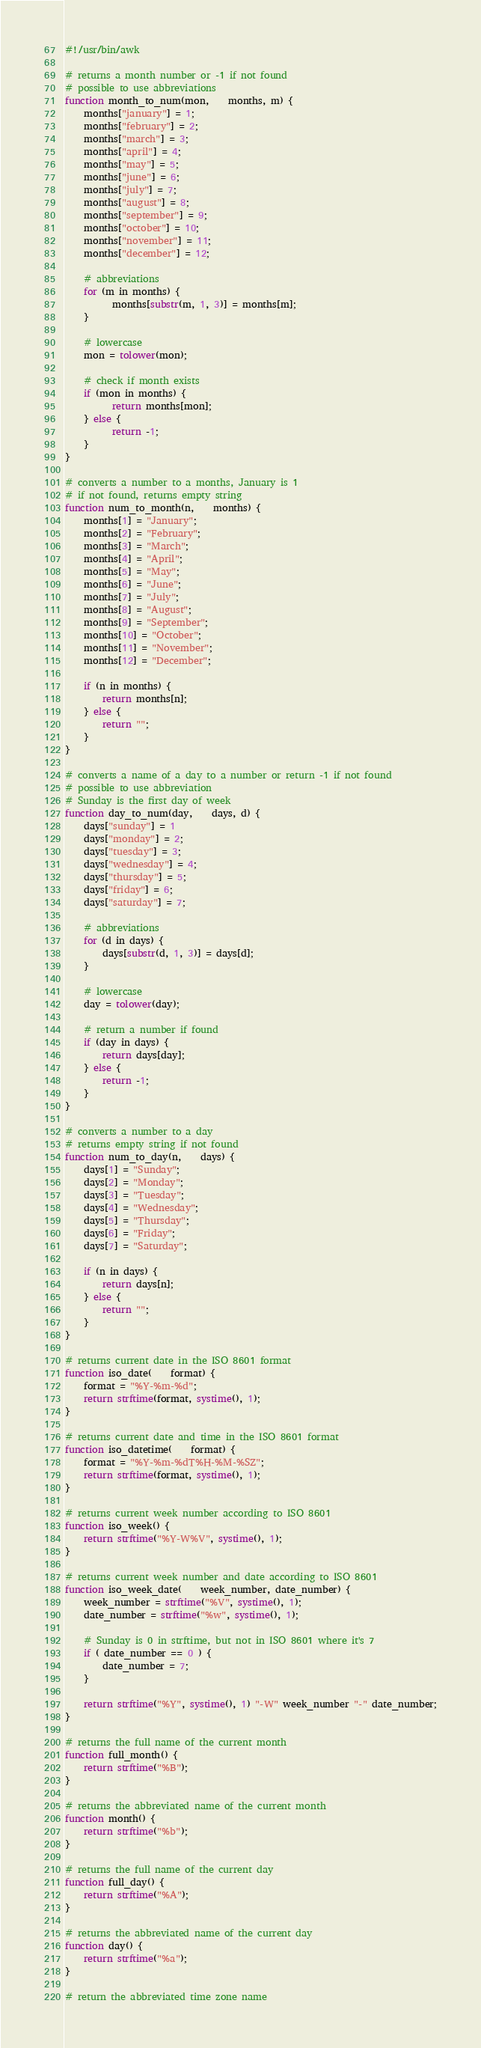Convert code to text. <code><loc_0><loc_0><loc_500><loc_500><_Awk_>#!/usr/bin/awk

# returns a month number or -1 if not found
# possible to use abbreviations
function month_to_num(mon,    months, m) {
	months["january"] = 1;
	months["february"] = 2;
	months["march"] = 3;
	months["april"] = 4;
	months["may"] = 5;
	months["june"] = 6;
	months["july"] = 7;
	months["august"] = 8;
	months["september"] = 9;
	months["october"] = 10;
	months["november"] = 11;
	months["december"] = 12;

	# abbreviations
	for (m in months) {
	      months[substr(m, 1, 3)] = months[m];
	}

	# lowercase
	mon = tolower(mon);

	# check if month exists
	if (mon in months) {
	      return months[mon];
	} else {
	      return -1;
	}
}

# converts a number to a months, January is 1
# if not found, returns empty string
function num_to_month(n,    months) {
	months[1] = "January";
	months[2] = "February";
	months[3] = "March";
	months[4] = "April";
	months[5] = "May";
	months[6] = "June";
	months[7] = "July";
	months[8] = "August";
	months[9] = "September";
	months[10] = "October";
	months[11] = "November";
	months[12] = "December";

	if (n in months) {
		return months[n];
	} else {
		return "";
	}	
}

# converts a name of a day to a number or return -1 if not found
# possible to use abbreviation
# Sunday is the first day of week
function day_to_num(day,    days, d) {
	days["sunday"] = 1
	days["monday"] = 2;
	days["tuesday"] = 3;
	days["wednesday"] = 4;
	days["thursday"] = 5;
	days["friday"] = 6;
	days["saturday"] = 7;
	
	# abbreviations
	for (d in days) {
		days[substr(d, 1, 3)] = days[d];
	}

	# lowercase
	day = tolower(day);

	# return a number if found
	if (day in days) {
		return days[day];
	} else {
		return -1;
	}
}

# converts a number to a day
# returns empty string if not found
function num_to_day(n,    days) {
	days[1] = "Sunday";	
	days[2] = "Monday";
	days[3] = "Tuesday";
	days[4] = "Wednesday";
	days[5] = "Thursday";
	days[6] = "Friday";
	days[7] = "Saturday";

	if (n in days) {
		return days[n];
	} else {
		return "";
	}
}

# returns current date in the ISO 8601 format
function iso_date(    format) {
	format = "%Y-%m-%d";
	return strftime(format, systime(), 1);
}

# returns current date and time in the ISO 8601 format
function iso_datetime(    format) {
	format = "%Y-%m-%dT%H-%M-%SZ";
	return strftime(format, systime(), 1);
}

# returns current week number according to ISO 8601
function iso_week() {
	return strftime("%Y-W%V", systime(), 1);
}

# returns current week number and date according to ISO 8601
function iso_week_date(    week_number, date_number) {
	week_number = strftime("%V", systime(), 1);
	date_number = strftime("%w", systime(), 1);

	# Sunday is 0 in strftime, but not in ISO 8601 where it's 7
	if ( date_number == 0 ) {
		date_number = 7;
	}

	return strftime("%Y", systime(), 1) "-W" week_number "-" date_number;
}

# returns the full name of the current month
function full_month() {
	return strftime("%B");	
}

# returns the abbreviated name of the current month
function month() {
	return strftime("%b");
}

# returns the full name of the current day
function full_day() {
	return strftime("%A");
}

# returns the abbreviated name of the current day
function day() {
	return strftime("%a");
}

# return the abbreviated time zone name</code> 